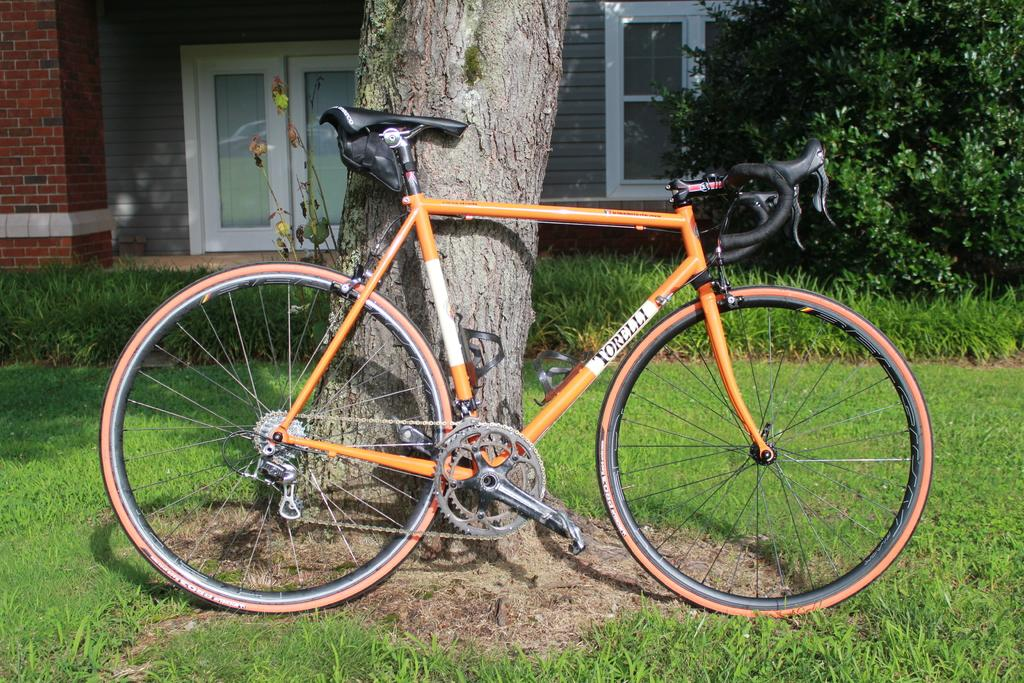What is the main object in the center of the image? There is a bicycle in the center of the image. What can be seen in the background of the image? There is a tree and a building in the background of the image. What type of vegetation is on the right side of the image? There is a bush on the right side of the image. What type of ground is visible at the bottom of the image? There is grass at the bottom of the image. What type of bread is being used as a reward for the bicycle in the image? There is no bread or reward present in the image; it features a bicycle, a tree, a building, a bush, and grass. 